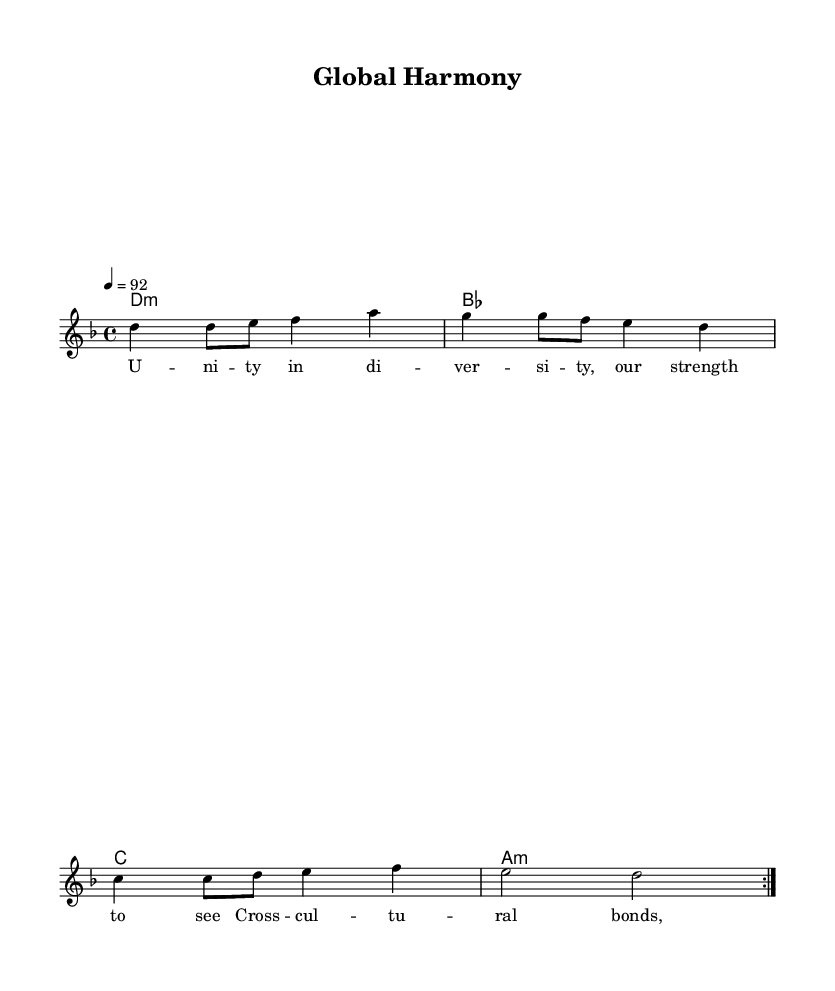What is the key signature of this music? The key signature is D minor, which has one flat (B flat). This is determined by looking at the key signature section at the beginning of the piece.
Answer: D minor What is the time signature of this music? The time signature is 4/4, indicating that there are four beats in each measure and the quarter note gets one beat. This can be seen at the beginning of the sheet music where the time signature is indicated.
Answer: 4/4 What is the tempo marking for this piece? The tempo marking is 92 beats per minute, which signifies the speed at which the piece should be performed. This is indicated near the beginning of the score.
Answer: 92 How many times is the melody repeated? The melody is repeated twice, as indicated by the "repeat volta 2" notation in the staff for the melody. This notation directs the musician to play the section two times.
Answer: 2 What musical genre does this piece represent? The piece represents Hip Hop, as evidenced by its lyrical content, themes of unity and cross-cultural understanding, and its stylistic elements fitting within the genre.
Answer: Hip Hop What theme is expressed in the lyrics? The theme expressed in the lyrics is unity in diversity, emphasizing collaboration and cultural bonds. This can be inferred from the lyrical content that speaks of global family and strength.
Answer: Unity What type of harmony is used in this sheet music? The harmony features major and minor chords as indicated by the chord names provided in the score. The chord mode provides a mix of minor and major tonalities, typical in Hip Hop.
Answer: Major and minor 